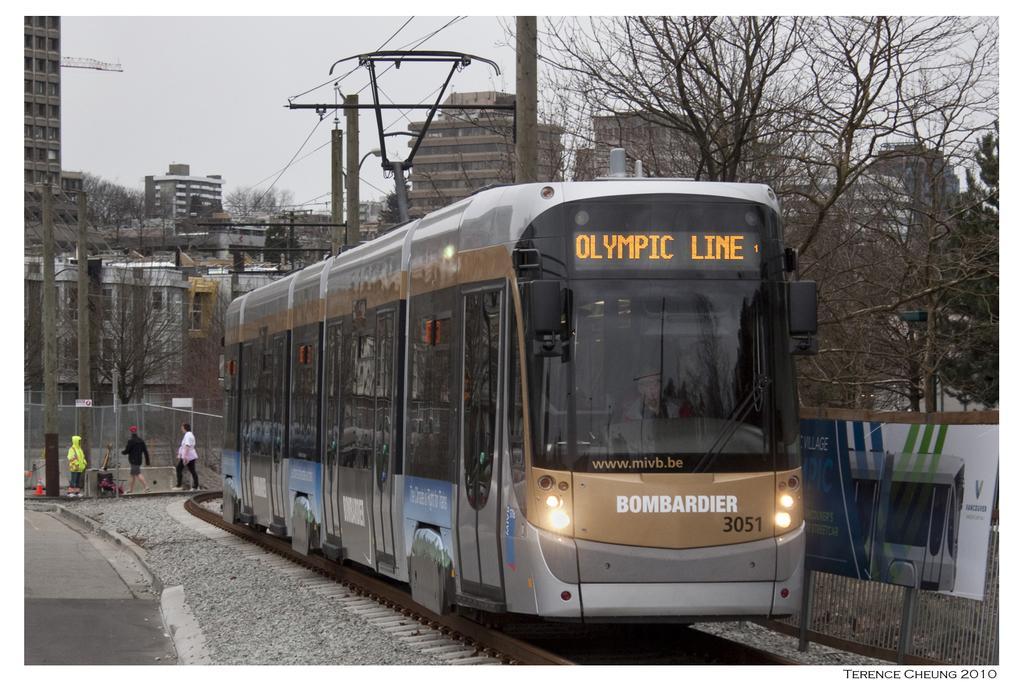In one or two sentences, can you explain what this image depicts? In this image I can see the train on the track. The train is in black and gray color and I can also see group of people standing. In the background I can see few electric poles, few trees, buildings and the sky is in white color. 